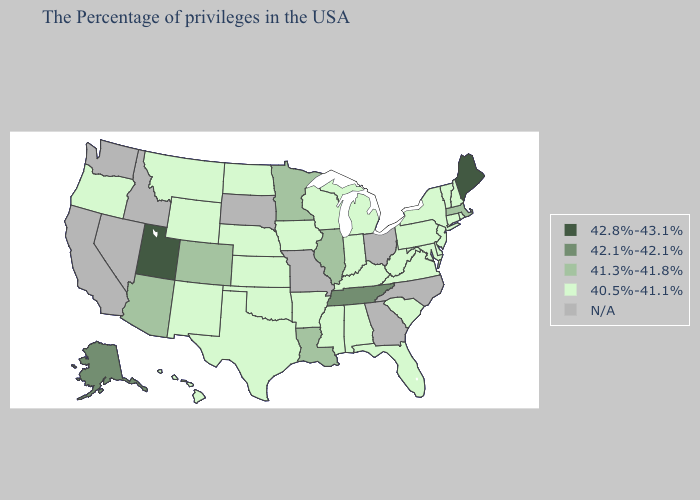Name the states that have a value in the range 42.8%-43.1%?
Give a very brief answer. Maine, Utah. Which states have the lowest value in the Northeast?
Concise answer only. Rhode Island, New Hampshire, Vermont, Connecticut, New York, New Jersey, Pennsylvania. Among the states that border South Dakota , does Minnesota have the highest value?
Concise answer only. Yes. What is the lowest value in the USA?
Short answer required. 40.5%-41.1%. Name the states that have a value in the range 40.5%-41.1%?
Answer briefly. Rhode Island, New Hampshire, Vermont, Connecticut, New York, New Jersey, Delaware, Maryland, Pennsylvania, Virginia, South Carolina, West Virginia, Florida, Michigan, Kentucky, Indiana, Alabama, Wisconsin, Mississippi, Arkansas, Iowa, Kansas, Nebraska, Oklahoma, Texas, North Dakota, Wyoming, New Mexico, Montana, Oregon, Hawaii. Among the states that border Virginia , does Tennessee have the lowest value?
Short answer required. No. What is the value of West Virginia?
Quick response, please. 40.5%-41.1%. Does Connecticut have the highest value in the Northeast?
Keep it brief. No. What is the value of Alabama?
Give a very brief answer. 40.5%-41.1%. Is the legend a continuous bar?
Short answer required. No. Name the states that have a value in the range 42.8%-43.1%?
Quick response, please. Maine, Utah. 